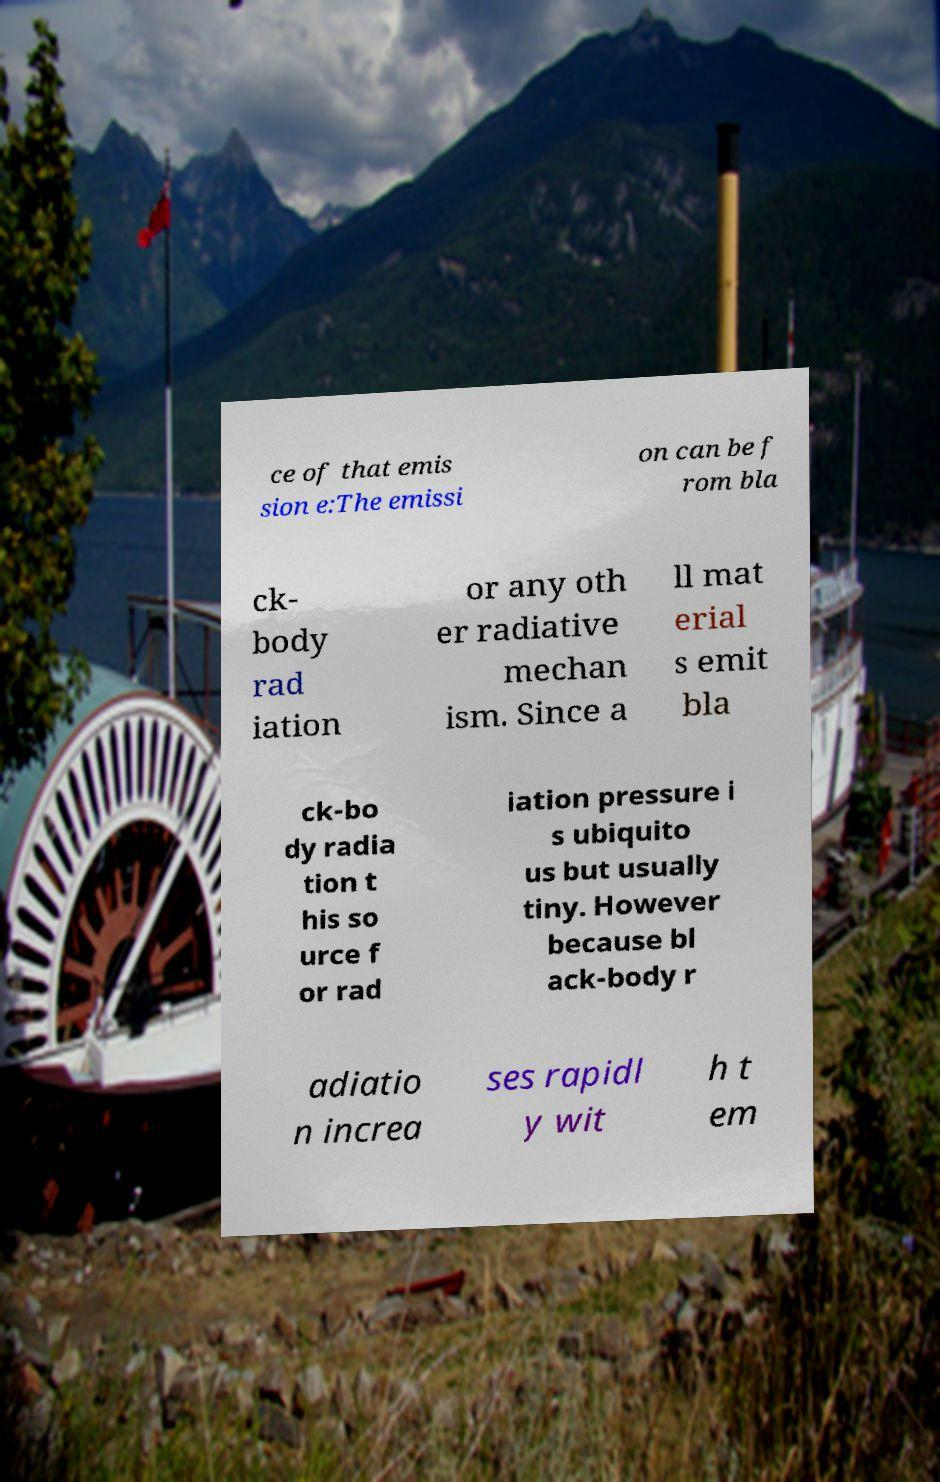What messages or text are displayed in this image? I need them in a readable, typed format. ce of that emis sion e:The emissi on can be f rom bla ck- body rad iation or any oth er radiative mechan ism. Since a ll mat erial s emit bla ck-bo dy radia tion t his so urce f or rad iation pressure i s ubiquito us but usually tiny. However because bl ack-body r adiatio n increa ses rapidl y wit h t em 